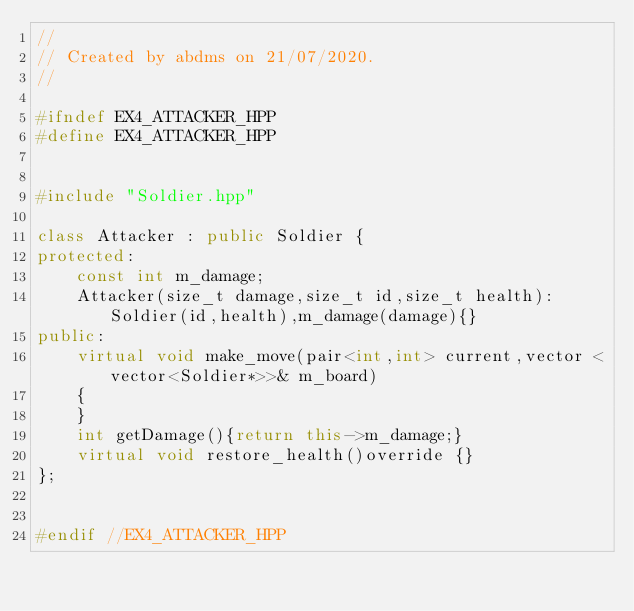<code> <loc_0><loc_0><loc_500><loc_500><_C++_>//
// Created by abdms on 21/07/2020.
//

#ifndef EX4_ATTACKER_HPP
#define EX4_ATTACKER_HPP


#include "Soldier.hpp"

class Attacker : public Soldier {
protected:
    const int m_damage;
    Attacker(size_t damage,size_t id,size_t health):Soldier(id,health),m_damage(damage){}
public:
    virtual void make_move(pair<int,int> current,vector <vector<Soldier*>>& m_board)
    {
    }
    int getDamage(){return this->m_damage;}
    virtual void restore_health()override {}
};


#endif //EX4_ATTACKER_HPP
</code> 